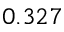<formula> <loc_0><loc_0><loc_500><loc_500>0 . 3 2 7</formula> 